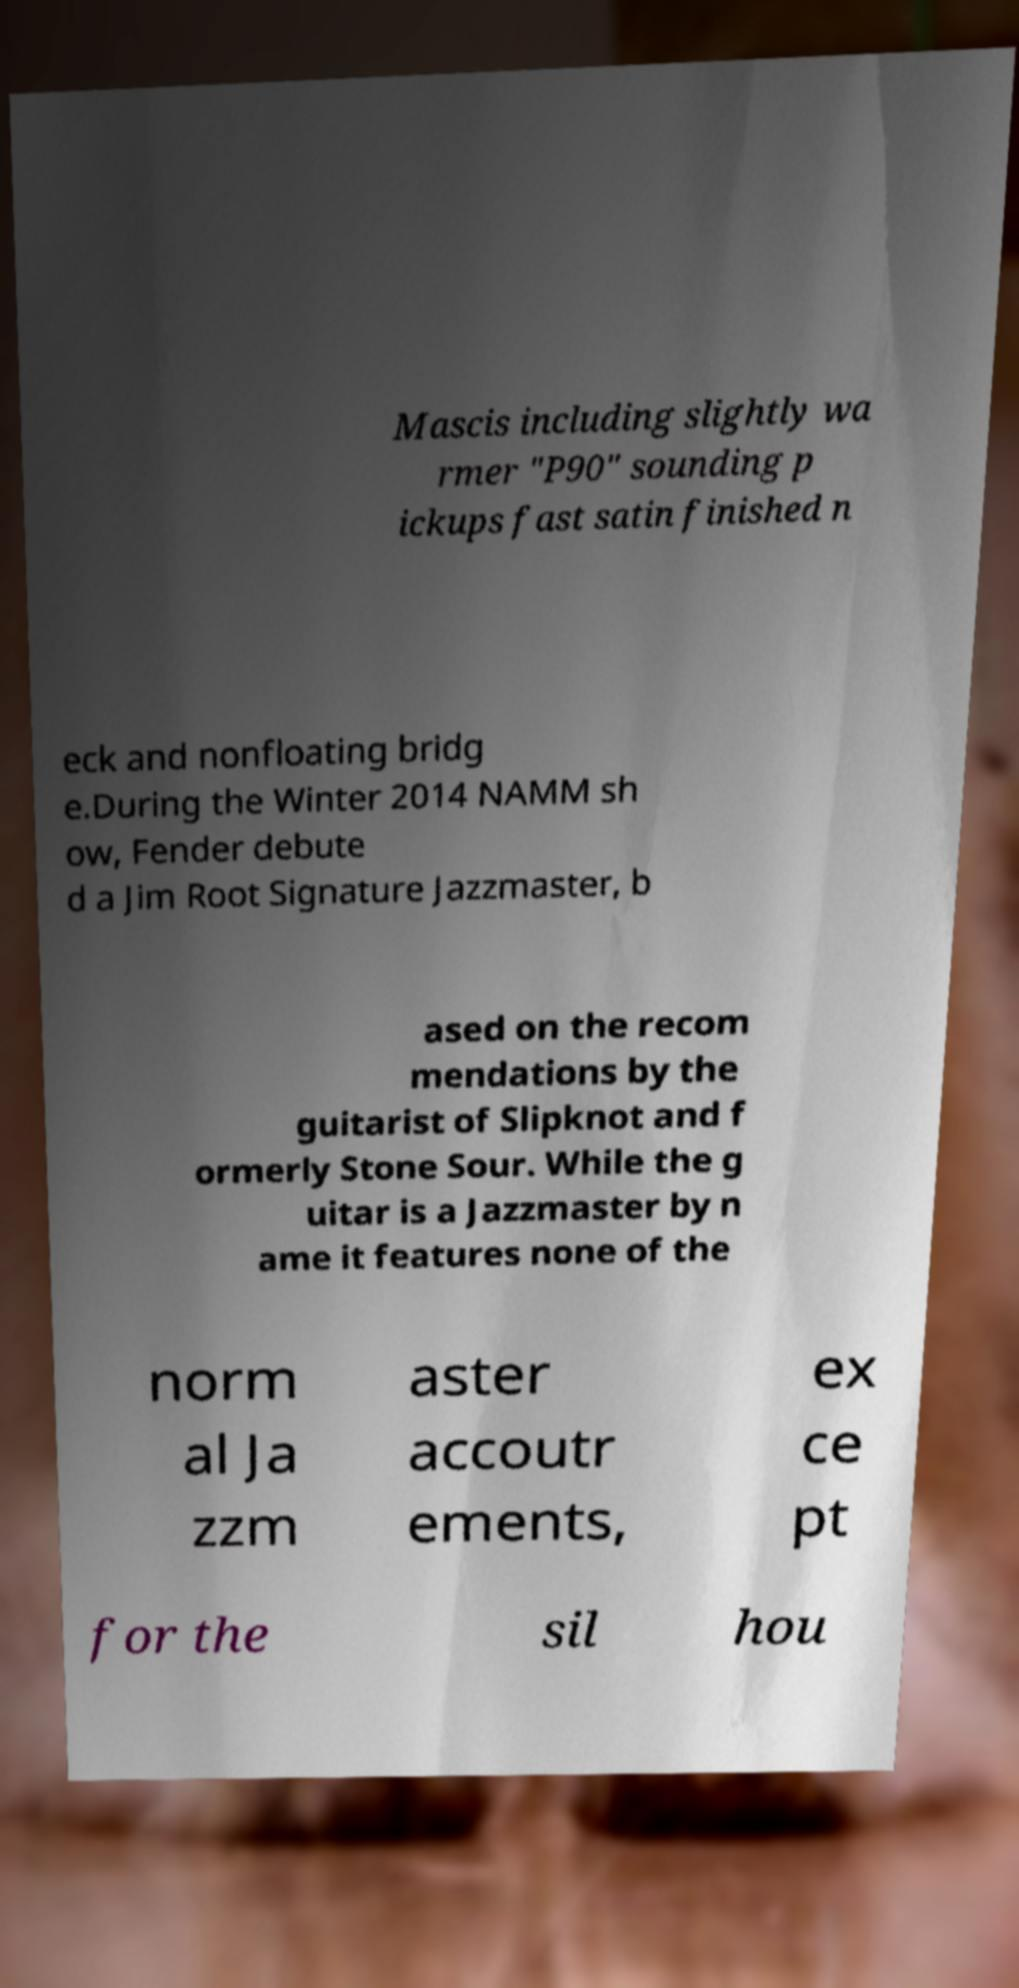Can you read and provide the text displayed in the image?This photo seems to have some interesting text. Can you extract and type it out for me? Mascis including slightly wa rmer "P90" sounding p ickups fast satin finished n eck and nonfloating bridg e.During the Winter 2014 NAMM sh ow, Fender debute d a Jim Root Signature Jazzmaster, b ased on the recom mendations by the guitarist of Slipknot and f ormerly Stone Sour. While the g uitar is a Jazzmaster by n ame it features none of the norm al Ja zzm aster accoutr ements, ex ce pt for the sil hou 